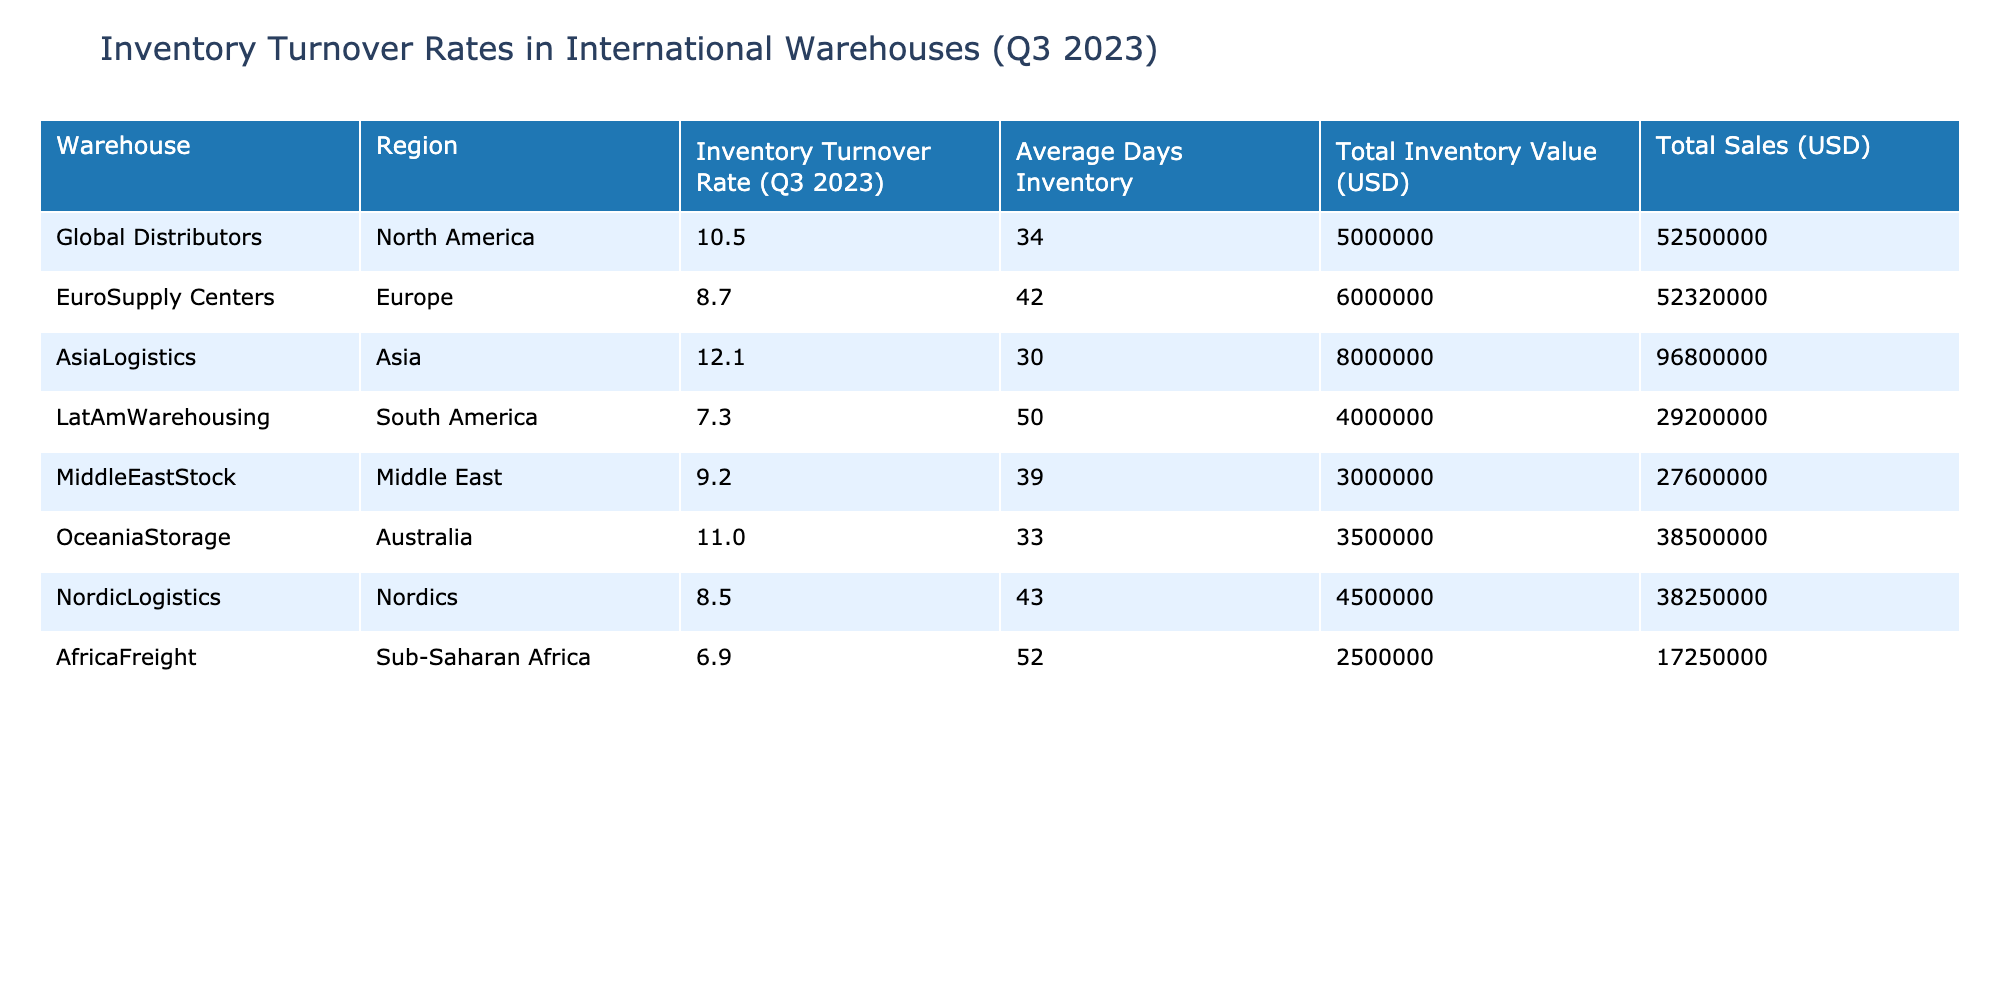What is the Inventory Turnover Rate for AsiaLogistics? The table lists AsiaLogistics with an Inventory Turnover Rate of 12.1.
Answer: 12.1 Which warehouse has the highest Total Sales? AsiaLogistics has the highest Total Sales at USD 96,800,000, compared to all other warehouses listed.
Answer: AsiaLogistics What is the average Inventory Turnover Rate across all warehouses? To find the average, sum all the Inventory Turnover Rates (10.5 + 8.7 + 12.1 + 7.3 + 9.2 + 11.0 + 8.5 + 6.9 = 74.2) and divide by the number of warehouses (8), resulting in an average of 74.2 / 8 = 9.275.
Answer: 9.3 Is the Inventory Turnover Rate for EuroSupply Centers greater than the average for all warehouses? The calculated average Inventory Turnover Rate is 9.275, and EuroSupply Centers has a rate of 8.7, which is less than the average.
Answer: No Which region has the lowest Inventory Turnover Rate? AfricaFreight in Sub-Saharan Africa has the lowest Inventory Turnover Rate at 6.9, making it the least efficient warehouse in terms of inventory turnover.
Answer: Sub-Saharan Africa What is the difference in Total Inventory Value between AsiaLogistics and LatAmWarehousing? The difference in Total Inventory Value is calculated by subtracting LatAmWarehousing's value (4,000,000) from AsiaLogistics' value (8,000,000), which equals 8,000,000 - 4,000,000 = 4,000,000.
Answer: 4,000,000 How many days of inventory does MiddleEastStock maintain? The table specifies that MiddleEastStock maintains 39 days of inventory.
Answer: 39 Which warehouse has the best Inventory Turnover Rate compared to others, and by how much does it exceed the next best? AsiaLogistics has the best Inventory Turnover Rate at 12.1, which exceeds OceaniaStorage's rate of 11.0 by 12.1 - 11.0 = 1.1.
Answer: It exceeds by 1.1 Is it true that all warehouses in Europe have an Inventory Turnover Rate above 8? EuroSupply Centers has an Inventory Turnover Rate of 8.7, NordicLogistics has 8.5, which is less than 8. Thus, it is not true that all European warehouses exceed 8.
Answer: No What is the Total Sales for the warehouse in the Middle East? The Total Sales for MiddleEastStock is listed at USD 27,600,000.
Answer: 27,600,000 